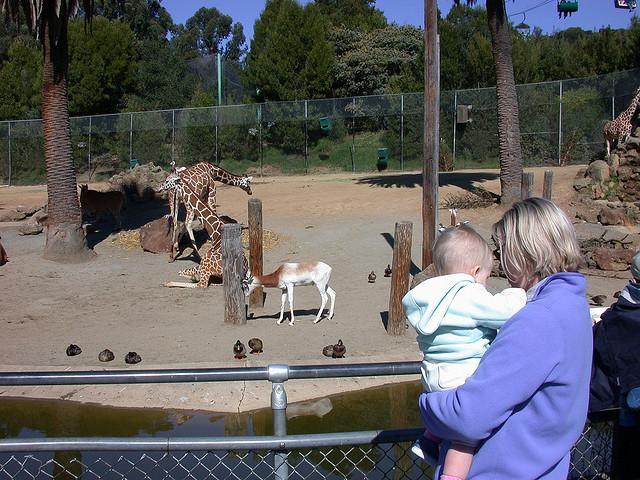What are the birds in the pen called? ducks 